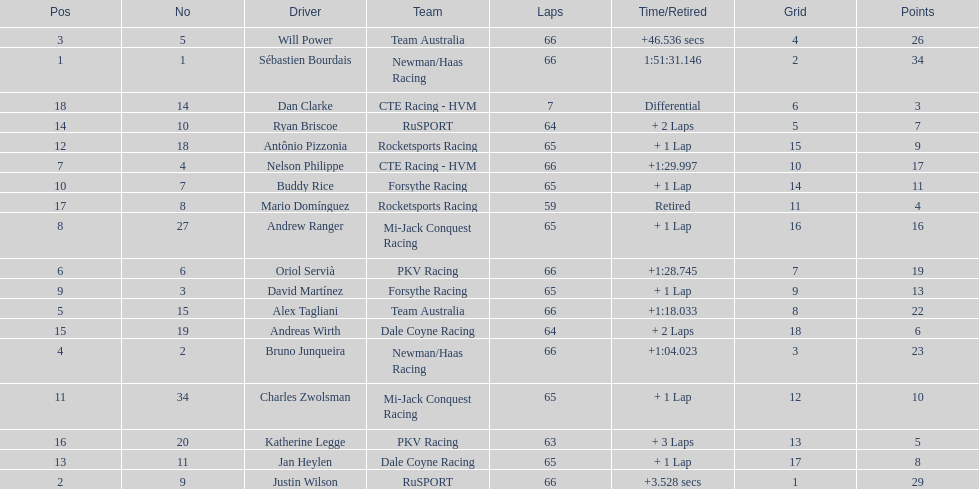At the 2006 gran premio telmex, who scored the highest number of points? Sébastien Bourdais. 